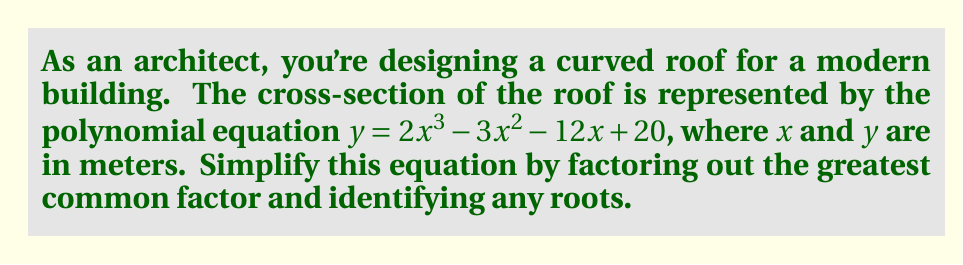Teach me how to tackle this problem. Let's approach this step-by-step:

1) First, we need to identify the greatest common factor (GCF) of all terms:
   $2x^3$, $-3x^2$, $-12x$, and $20$
   The GCF is 1, so we can't factor anything out.

2) Next, we'll check if this is a cubic function that can be factored:
   $f(x) = 2x^3 - 3x^2 - 12x + 20$

3) To find potential roots, we'll use the rational root theorem. The potential roots are the factors of the constant term (20) divided by the factors of the leading coefficient (2):
   $\pm 1, \pm 2, \pm 4, \pm 5, \pm 10, \pm 20, \pm \frac{1}{2}, \pm 1, \pm 2, \pm \frac{5}{2}, \pm 5, \pm 10$

4) Testing these values, we find that $x = 2$ is a root:
   $f(2) = 2(2)^3 - 3(2)^2 - 12(2) + 20 = 16 - 12 - 24 + 20 = 0$

5) So, $(x - 2)$ is a factor. We can use polynomial long division to find the other factor:

   $2x^3 - 3x^2 - 12x + 20 = (x - 2)(2x^2 + x + 10)$

6) The quadratic factor $2x^2 + x + 10$ cannot be factored further as its discriminant is negative:
   $b^2 - 4ac = 1^2 - 4(2)(10) = 1 - 80 = -79 < 0$

Therefore, the fully factored form is:

$y = (x - 2)(2x^2 + x + 10)$
Answer: $y = (x - 2)(2x^2 + x + 10)$ 